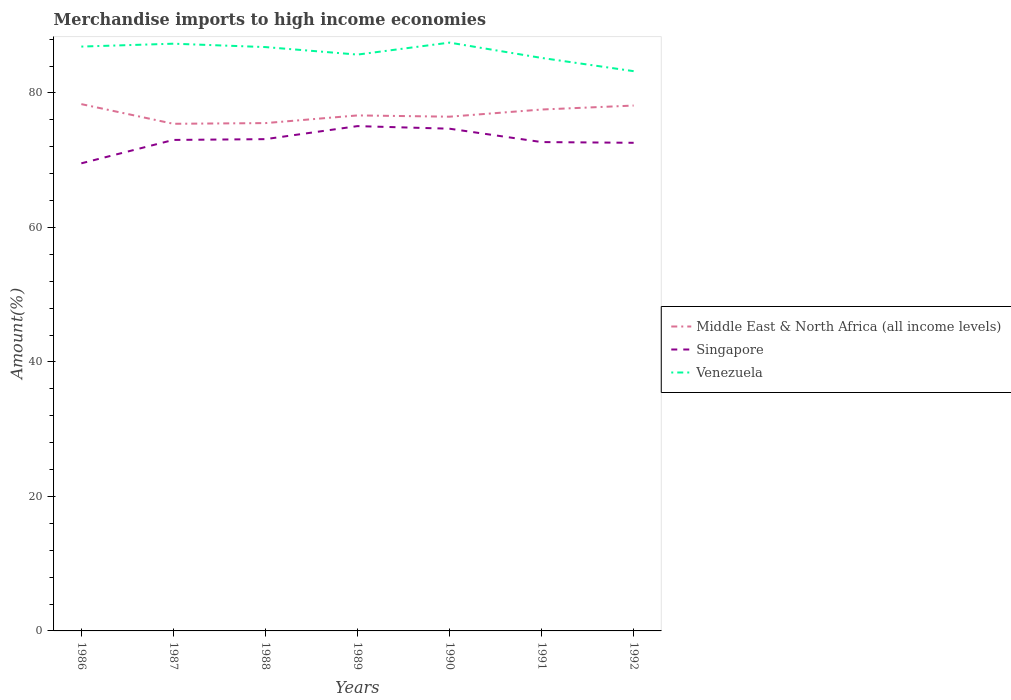How many different coloured lines are there?
Make the answer very short. 3. Does the line corresponding to Venezuela intersect with the line corresponding to Singapore?
Provide a succinct answer. No. Across all years, what is the maximum percentage of amount earned from merchandise imports in Middle East & North Africa (all income levels)?
Give a very brief answer. 75.41. In which year was the percentage of amount earned from merchandise imports in Venezuela maximum?
Offer a terse response. 1992. What is the total percentage of amount earned from merchandise imports in Singapore in the graph?
Keep it short and to the point. -1.55. What is the difference between the highest and the second highest percentage of amount earned from merchandise imports in Middle East & North Africa (all income levels)?
Your response must be concise. 2.93. Is the percentage of amount earned from merchandise imports in Venezuela strictly greater than the percentage of amount earned from merchandise imports in Singapore over the years?
Your answer should be very brief. No. How many lines are there?
Your response must be concise. 3. How many years are there in the graph?
Ensure brevity in your answer.  7. What is the difference between two consecutive major ticks on the Y-axis?
Provide a succinct answer. 20. Does the graph contain grids?
Offer a very short reply. No. How are the legend labels stacked?
Provide a short and direct response. Vertical. What is the title of the graph?
Your response must be concise. Merchandise imports to high income economies. What is the label or title of the Y-axis?
Your response must be concise. Amount(%). What is the Amount(%) in Middle East & North Africa (all income levels) in 1986?
Ensure brevity in your answer.  78.33. What is the Amount(%) of Singapore in 1986?
Your answer should be very brief. 69.53. What is the Amount(%) of Venezuela in 1986?
Offer a very short reply. 86.89. What is the Amount(%) in Middle East & North Africa (all income levels) in 1987?
Make the answer very short. 75.41. What is the Amount(%) in Singapore in 1987?
Make the answer very short. 73.01. What is the Amount(%) of Venezuela in 1987?
Provide a succinct answer. 87.32. What is the Amount(%) in Middle East & North Africa (all income levels) in 1988?
Your response must be concise. 75.51. What is the Amount(%) in Singapore in 1988?
Keep it short and to the point. 73.12. What is the Amount(%) of Venezuela in 1988?
Provide a short and direct response. 86.81. What is the Amount(%) of Middle East & North Africa (all income levels) in 1989?
Keep it short and to the point. 76.65. What is the Amount(%) of Singapore in 1989?
Offer a very short reply. 75.06. What is the Amount(%) of Venezuela in 1989?
Your answer should be very brief. 85.7. What is the Amount(%) of Middle East & North Africa (all income levels) in 1990?
Your answer should be compact. 76.46. What is the Amount(%) of Singapore in 1990?
Provide a short and direct response. 74.68. What is the Amount(%) in Venezuela in 1990?
Your response must be concise. 87.48. What is the Amount(%) in Middle East & North Africa (all income levels) in 1991?
Provide a succinct answer. 77.53. What is the Amount(%) of Singapore in 1991?
Your answer should be compact. 72.69. What is the Amount(%) of Venezuela in 1991?
Keep it short and to the point. 85.2. What is the Amount(%) in Middle East & North Africa (all income levels) in 1992?
Make the answer very short. 78.12. What is the Amount(%) in Singapore in 1992?
Keep it short and to the point. 72.58. What is the Amount(%) in Venezuela in 1992?
Provide a short and direct response. 83.23. Across all years, what is the maximum Amount(%) in Middle East & North Africa (all income levels)?
Your answer should be very brief. 78.33. Across all years, what is the maximum Amount(%) in Singapore?
Your response must be concise. 75.06. Across all years, what is the maximum Amount(%) in Venezuela?
Keep it short and to the point. 87.48. Across all years, what is the minimum Amount(%) of Middle East & North Africa (all income levels)?
Ensure brevity in your answer.  75.41. Across all years, what is the minimum Amount(%) in Singapore?
Give a very brief answer. 69.53. Across all years, what is the minimum Amount(%) in Venezuela?
Your answer should be compact. 83.23. What is the total Amount(%) of Middle East & North Africa (all income levels) in the graph?
Ensure brevity in your answer.  538.02. What is the total Amount(%) in Singapore in the graph?
Keep it short and to the point. 510.68. What is the total Amount(%) of Venezuela in the graph?
Your answer should be very brief. 602.63. What is the difference between the Amount(%) in Middle East & North Africa (all income levels) in 1986 and that in 1987?
Offer a terse response. 2.93. What is the difference between the Amount(%) in Singapore in 1986 and that in 1987?
Your answer should be very brief. -3.48. What is the difference between the Amount(%) in Venezuela in 1986 and that in 1987?
Keep it short and to the point. -0.43. What is the difference between the Amount(%) of Middle East & North Africa (all income levels) in 1986 and that in 1988?
Your answer should be very brief. 2.82. What is the difference between the Amount(%) in Singapore in 1986 and that in 1988?
Ensure brevity in your answer.  -3.6. What is the difference between the Amount(%) of Venezuela in 1986 and that in 1988?
Your response must be concise. 0.07. What is the difference between the Amount(%) of Middle East & North Africa (all income levels) in 1986 and that in 1989?
Make the answer very short. 1.68. What is the difference between the Amount(%) of Singapore in 1986 and that in 1989?
Provide a succinct answer. -5.53. What is the difference between the Amount(%) of Venezuela in 1986 and that in 1989?
Provide a short and direct response. 1.19. What is the difference between the Amount(%) in Middle East & North Africa (all income levels) in 1986 and that in 1990?
Make the answer very short. 1.87. What is the difference between the Amount(%) in Singapore in 1986 and that in 1990?
Offer a terse response. -5.15. What is the difference between the Amount(%) of Venezuela in 1986 and that in 1990?
Provide a succinct answer. -0.59. What is the difference between the Amount(%) in Middle East & North Africa (all income levels) in 1986 and that in 1991?
Your response must be concise. 0.8. What is the difference between the Amount(%) in Singapore in 1986 and that in 1991?
Ensure brevity in your answer.  -3.16. What is the difference between the Amount(%) in Venezuela in 1986 and that in 1991?
Make the answer very short. 1.69. What is the difference between the Amount(%) of Middle East & North Africa (all income levels) in 1986 and that in 1992?
Your response must be concise. 0.21. What is the difference between the Amount(%) in Singapore in 1986 and that in 1992?
Your answer should be compact. -3.05. What is the difference between the Amount(%) in Venezuela in 1986 and that in 1992?
Your answer should be compact. 3.66. What is the difference between the Amount(%) of Middle East & North Africa (all income levels) in 1987 and that in 1988?
Provide a succinct answer. -0.1. What is the difference between the Amount(%) in Singapore in 1987 and that in 1988?
Your response must be concise. -0.12. What is the difference between the Amount(%) in Venezuela in 1987 and that in 1988?
Offer a terse response. 0.5. What is the difference between the Amount(%) in Middle East & North Africa (all income levels) in 1987 and that in 1989?
Offer a terse response. -1.24. What is the difference between the Amount(%) of Singapore in 1987 and that in 1989?
Offer a terse response. -2.05. What is the difference between the Amount(%) of Venezuela in 1987 and that in 1989?
Give a very brief answer. 1.62. What is the difference between the Amount(%) of Middle East & North Africa (all income levels) in 1987 and that in 1990?
Keep it short and to the point. -1.06. What is the difference between the Amount(%) of Singapore in 1987 and that in 1990?
Give a very brief answer. -1.67. What is the difference between the Amount(%) of Venezuela in 1987 and that in 1990?
Make the answer very short. -0.16. What is the difference between the Amount(%) in Middle East & North Africa (all income levels) in 1987 and that in 1991?
Give a very brief answer. -2.12. What is the difference between the Amount(%) in Singapore in 1987 and that in 1991?
Make the answer very short. 0.32. What is the difference between the Amount(%) of Venezuela in 1987 and that in 1991?
Provide a short and direct response. 2.12. What is the difference between the Amount(%) in Middle East & North Africa (all income levels) in 1987 and that in 1992?
Provide a succinct answer. -2.71. What is the difference between the Amount(%) of Singapore in 1987 and that in 1992?
Offer a very short reply. 0.43. What is the difference between the Amount(%) of Venezuela in 1987 and that in 1992?
Ensure brevity in your answer.  4.08. What is the difference between the Amount(%) of Middle East & North Africa (all income levels) in 1988 and that in 1989?
Offer a terse response. -1.14. What is the difference between the Amount(%) in Singapore in 1988 and that in 1989?
Your answer should be compact. -1.94. What is the difference between the Amount(%) in Venezuela in 1988 and that in 1989?
Your answer should be very brief. 1.12. What is the difference between the Amount(%) in Middle East & North Africa (all income levels) in 1988 and that in 1990?
Provide a short and direct response. -0.95. What is the difference between the Amount(%) of Singapore in 1988 and that in 1990?
Offer a very short reply. -1.55. What is the difference between the Amount(%) of Venezuela in 1988 and that in 1990?
Your response must be concise. -0.66. What is the difference between the Amount(%) of Middle East & North Africa (all income levels) in 1988 and that in 1991?
Your response must be concise. -2.02. What is the difference between the Amount(%) in Singapore in 1988 and that in 1991?
Ensure brevity in your answer.  0.44. What is the difference between the Amount(%) in Venezuela in 1988 and that in 1991?
Make the answer very short. 1.61. What is the difference between the Amount(%) of Middle East & North Africa (all income levels) in 1988 and that in 1992?
Offer a terse response. -2.61. What is the difference between the Amount(%) in Singapore in 1988 and that in 1992?
Provide a succinct answer. 0.54. What is the difference between the Amount(%) in Venezuela in 1988 and that in 1992?
Keep it short and to the point. 3.58. What is the difference between the Amount(%) of Middle East & North Africa (all income levels) in 1989 and that in 1990?
Your response must be concise. 0.19. What is the difference between the Amount(%) of Singapore in 1989 and that in 1990?
Your answer should be very brief. 0.38. What is the difference between the Amount(%) of Venezuela in 1989 and that in 1990?
Keep it short and to the point. -1.78. What is the difference between the Amount(%) of Middle East & North Africa (all income levels) in 1989 and that in 1991?
Make the answer very short. -0.88. What is the difference between the Amount(%) of Singapore in 1989 and that in 1991?
Provide a short and direct response. 2.37. What is the difference between the Amount(%) of Venezuela in 1989 and that in 1991?
Offer a very short reply. 0.5. What is the difference between the Amount(%) in Middle East & North Africa (all income levels) in 1989 and that in 1992?
Make the answer very short. -1.47. What is the difference between the Amount(%) in Singapore in 1989 and that in 1992?
Your answer should be compact. 2.48. What is the difference between the Amount(%) of Venezuela in 1989 and that in 1992?
Your response must be concise. 2.46. What is the difference between the Amount(%) in Middle East & North Africa (all income levels) in 1990 and that in 1991?
Ensure brevity in your answer.  -1.06. What is the difference between the Amount(%) of Singapore in 1990 and that in 1991?
Ensure brevity in your answer.  1.99. What is the difference between the Amount(%) in Venezuela in 1990 and that in 1991?
Give a very brief answer. 2.28. What is the difference between the Amount(%) in Middle East & North Africa (all income levels) in 1990 and that in 1992?
Give a very brief answer. -1.66. What is the difference between the Amount(%) in Singapore in 1990 and that in 1992?
Keep it short and to the point. 2.09. What is the difference between the Amount(%) of Venezuela in 1990 and that in 1992?
Ensure brevity in your answer.  4.25. What is the difference between the Amount(%) of Middle East & North Africa (all income levels) in 1991 and that in 1992?
Your answer should be compact. -0.59. What is the difference between the Amount(%) in Singapore in 1991 and that in 1992?
Your answer should be very brief. 0.11. What is the difference between the Amount(%) of Venezuela in 1991 and that in 1992?
Make the answer very short. 1.97. What is the difference between the Amount(%) of Middle East & North Africa (all income levels) in 1986 and the Amount(%) of Singapore in 1987?
Your answer should be compact. 5.33. What is the difference between the Amount(%) of Middle East & North Africa (all income levels) in 1986 and the Amount(%) of Venezuela in 1987?
Give a very brief answer. -8.98. What is the difference between the Amount(%) of Singapore in 1986 and the Amount(%) of Venezuela in 1987?
Give a very brief answer. -17.79. What is the difference between the Amount(%) of Middle East & North Africa (all income levels) in 1986 and the Amount(%) of Singapore in 1988?
Ensure brevity in your answer.  5.21. What is the difference between the Amount(%) in Middle East & North Africa (all income levels) in 1986 and the Amount(%) in Venezuela in 1988?
Your answer should be compact. -8.48. What is the difference between the Amount(%) of Singapore in 1986 and the Amount(%) of Venezuela in 1988?
Ensure brevity in your answer.  -17.28. What is the difference between the Amount(%) of Middle East & North Africa (all income levels) in 1986 and the Amount(%) of Singapore in 1989?
Ensure brevity in your answer.  3.27. What is the difference between the Amount(%) of Middle East & North Africa (all income levels) in 1986 and the Amount(%) of Venezuela in 1989?
Your answer should be very brief. -7.36. What is the difference between the Amount(%) in Singapore in 1986 and the Amount(%) in Venezuela in 1989?
Offer a very short reply. -16.17. What is the difference between the Amount(%) in Middle East & North Africa (all income levels) in 1986 and the Amount(%) in Singapore in 1990?
Keep it short and to the point. 3.66. What is the difference between the Amount(%) in Middle East & North Africa (all income levels) in 1986 and the Amount(%) in Venezuela in 1990?
Your answer should be very brief. -9.15. What is the difference between the Amount(%) in Singapore in 1986 and the Amount(%) in Venezuela in 1990?
Your response must be concise. -17.95. What is the difference between the Amount(%) of Middle East & North Africa (all income levels) in 1986 and the Amount(%) of Singapore in 1991?
Keep it short and to the point. 5.64. What is the difference between the Amount(%) in Middle East & North Africa (all income levels) in 1986 and the Amount(%) in Venezuela in 1991?
Your response must be concise. -6.87. What is the difference between the Amount(%) in Singapore in 1986 and the Amount(%) in Venezuela in 1991?
Your answer should be compact. -15.67. What is the difference between the Amount(%) in Middle East & North Africa (all income levels) in 1986 and the Amount(%) in Singapore in 1992?
Keep it short and to the point. 5.75. What is the difference between the Amount(%) of Middle East & North Africa (all income levels) in 1986 and the Amount(%) of Venezuela in 1992?
Keep it short and to the point. -4.9. What is the difference between the Amount(%) in Singapore in 1986 and the Amount(%) in Venezuela in 1992?
Give a very brief answer. -13.7. What is the difference between the Amount(%) of Middle East & North Africa (all income levels) in 1987 and the Amount(%) of Singapore in 1988?
Give a very brief answer. 2.28. What is the difference between the Amount(%) of Middle East & North Africa (all income levels) in 1987 and the Amount(%) of Venezuela in 1988?
Your answer should be very brief. -11.41. What is the difference between the Amount(%) in Singapore in 1987 and the Amount(%) in Venezuela in 1988?
Ensure brevity in your answer.  -13.81. What is the difference between the Amount(%) in Middle East & North Africa (all income levels) in 1987 and the Amount(%) in Singapore in 1989?
Your answer should be compact. 0.35. What is the difference between the Amount(%) of Middle East & North Africa (all income levels) in 1987 and the Amount(%) of Venezuela in 1989?
Your answer should be compact. -10.29. What is the difference between the Amount(%) of Singapore in 1987 and the Amount(%) of Venezuela in 1989?
Provide a short and direct response. -12.69. What is the difference between the Amount(%) in Middle East & North Africa (all income levels) in 1987 and the Amount(%) in Singapore in 1990?
Offer a terse response. 0.73. What is the difference between the Amount(%) of Middle East & North Africa (all income levels) in 1987 and the Amount(%) of Venezuela in 1990?
Provide a short and direct response. -12.07. What is the difference between the Amount(%) in Singapore in 1987 and the Amount(%) in Venezuela in 1990?
Give a very brief answer. -14.47. What is the difference between the Amount(%) of Middle East & North Africa (all income levels) in 1987 and the Amount(%) of Singapore in 1991?
Ensure brevity in your answer.  2.72. What is the difference between the Amount(%) of Middle East & North Africa (all income levels) in 1987 and the Amount(%) of Venezuela in 1991?
Keep it short and to the point. -9.79. What is the difference between the Amount(%) in Singapore in 1987 and the Amount(%) in Venezuela in 1991?
Your response must be concise. -12.19. What is the difference between the Amount(%) of Middle East & North Africa (all income levels) in 1987 and the Amount(%) of Singapore in 1992?
Your answer should be very brief. 2.83. What is the difference between the Amount(%) in Middle East & North Africa (all income levels) in 1987 and the Amount(%) in Venezuela in 1992?
Your answer should be compact. -7.83. What is the difference between the Amount(%) in Singapore in 1987 and the Amount(%) in Venezuela in 1992?
Keep it short and to the point. -10.23. What is the difference between the Amount(%) of Middle East & North Africa (all income levels) in 1988 and the Amount(%) of Singapore in 1989?
Make the answer very short. 0.45. What is the difference between the Amount(%) of Middle East & North Africa (all income levels) in 1988 and the Amount(%) of Venezuela in 1989?
Give a very brief answer. -10.19. What is the difference between the Amount(%) in Singapore in 1988 and the Amount(%) in Venezuela in 1989?
Your answer should be compact. -12.57. What is the difference between the Amount(%) of Middle East & North Africa (all income levels) in 1988 and the Amount(%) of Singapore in 1990?
Make the answer very short. 0.83. What is the difference between the Amount(%) of Middle East & North Africa (all income levels) in 1988 and the Amount(%) of Venezuela in 1990?
Keep it short and to the point. -11.97. What is the difference between the Amount(%) in Singapore in 1988 and the Amount(%) in Venezuela in 1990?
Make the answer very short. -14.35. What is the difference between the Amount(%) of Middle East & North Africa (all income levels) in 1988 and the Amount(%) of Singapore in 1991?
Your answer should be very brief. 2.82. What is the difference between the Amount(%) of Middle East & North Africa (all income levels) in 1988 and the Amount(%) of Venezuela in 1991?
Provide a short and direct response. -9.69. What is the difference between the Amount(%) in Singapore in 1988 and the Amount(%) in Venezuela in 1991?
Keep it short and to the point. -12.08. What is the difference between the Amount(%) in Middle East & North Africa (all income levels) in 1988 and the Amount(%) in Singapore in 1992?
Offer a terse response. 2.93. What is the difference between the Amount(%) in Middle East & North Africa (all income levels) in 1988 and the Amount(%) in Venezuela in 1992?
Offer a terse response. -7.72. What is the difference between the Amount(%) of Singapore in 1988 and the Amount(%) of Venezuela in 1992?
Provide a short and direct response. -10.11. What is the difference between the Amount(%) of Middle East & North Africa (all income levels) in 1989 and the Amount(%) of Singapore in 1990?
Ensure brevity in your answer.  1.98. What is the difference between the Amount(%) in Middle East & North Africa (all income levels) in 1989 and the Amount(%) in Venezuela in 1990?
Your answer should be compact. -10.83. What is the difference between the Amount(%) of Singapore in 1989 and the Amount(%) of Venezuela in 1990?
Your answer should be compact. -12.42. What is the difference between the Amount(%) in Middle East & North Africa (all income levels) in 1989 and the Amount(%) in Singapore in 1991?
Provide a succinct answer. 3.96. What is the difference between the Amount(%) in Middle East & North Africa (all income levels) in 1989 and the Amount(%) in Venezuela in 1991?
Provide a succinct answer. -8.55. What is the difference between the Amount(%) in Singapore in 1989 and the Amount(%) in Venezuela in 1991?
Your answer should be compact. -10.14. What is the difference between the Amount(%) of Middle East & North Africa (all income levels) in 1989 and the Amount(%) of Singapore in 1992?
Your answer should be very brief. 4.07. What is the difference between the Amount(%) of Middle East & North Africa (all income levels) in 1989 and the Amount(%) of Venezuela in 1992?
Keep it short and to the point. -6.58. What is the difference between the Amount(%) in Singapore in 1989 and the Amount(%) in Venezuela in 1992?
Keep it short and to the point. -8.17. What is the difference between the Amount(%) in Middle East & North Africa (all income levels) in 1990 and the Amount(%) in Singapore in 1991?
Offer a terse response. 3.77. What is the difference between the Amount(%) in Middle East & North Africa (all income levels) in 1990 and the Amount(%) in Venezuela in 1991?
Provide a succinct answer. -8.74. What is the difference between the Amount(%) of Singapore in 1990 and the Amount(%) of Venezuela in 1991?
Ensure brevity in your answer.  -10.52. What is the difference between the Amount(%) of Middle East & North Africa (all income levels) in 1990 and the Amount(%) of Singapore in 1992?
Keep it short and to the point. 3.88. What is the difference between the Amount(%) in Middle East & North Africa (all income levels) in 1990 and the Amount(%) in Venezuela in 1992?
Offer a very short reply. -6.77. What is the difference between the Amount(%) of Singapore in 1990 and the Amount(%) of Venezuela in 1992?
Your answer should be very brief. -8.56. What is the difference between the Amount(%) of Middle East & North Africa (all income levels) in 1991 and the Amount(%) of Singapore in 1992?
Give a very brief answer. 4.95. What is the difference between the Amount(%) of Middle East & North Africa (all income levels) in 1991 and the Amount(%) of Venezuela in 1992?
Offer a terse response. -5.7. What is the difference between the Amount(%) of Singapore in 1991 and the Amount(%) of Venezuela in 1992?
Make the answer very short. -10.54. What is the average Amount(%) in Middle East & North Africa (all income levels) per year?
Offer a very short reply. 76.86. What is the average Amount(%) in Singapore per year?
Offer a terse response. 72.95. What is the average Amount(%) of Venezuela per year?
Keep it short and to the point. 86.09. In the year 1986, what is the difference between the Amount(%) of Middle East & North Africa (all income levels) and Amount(%) of Singapore?
Your answer should be very brief. 8.8. In the year 1986, what is the difference between the Amount(%) of Middle East & North Africa (all income levels) and Amount(%) of Venezuela?
Your response must be concise. -8.55. In the year 1986, what is the difference between the Amount(%) in Singapore and Amount(%) in Venezuela?
Ensure brevity in your answer.  -17.36. In the year 1987, what is the difference between the Amount(%) of Middle East & North Africa (all income levels) and Amount(%) of Singapore?
Your answer should be very brief. 2.4. In the year 1987, what is the difference between the Amount(%) in Middle East & North Africa (all income levels) and Amount(%) in Venezuela?
Your response must be concise. -11.91. In the year 1987, what is the difference between the Amount(%) in Singapore and Amount(%) in Venezuela?
Give a very brief answer. -14.31. In the year 1988, what is the difference between the Amount(%) in Middle East & North Africa (all income levels) and Amount(%) in Singapore?
Ensure brevity in your answer.  2.39. In the year 1988, what is the difference between the Amount(%) of Middle East & North Africa (all income levels) and Amount(%) of Venezuela?
Make the answer very short. -11.3. In the year 1988, what is the difference between the Amount(%) of Singapore and Amount(%) of Venezuela?
Give a very brief answer. -13.69. In the year 1989, what is the difference between the Amount(%) of Middle East & North Africa (all income levels) and Amount(%) of Singapore?
Give a very brief answer. 1.59. In the year 1989, what is the difference between the Amount(%) in Middle East & North Africa (all income levels) and Amount(%) in Venezuela?
Provide a succinct answer. -9.05. In the year 1989, what is the difference between the Amount(%) of Singapore and Amount(%) of Venezuela?
Give a very brief answer. -10.64. In the year 1990, what is the difference between the Amount(%) of Middle East & North Africa (all income levels) and Amount(%) of Singapore?
Your response must be concise. 1.79. In the year 1990, what is the difference between the Amount(%) in Middle East & North Africa (all income levels) and Amount(%) in Venezuela?
Offer a terse response. -11.01. In the year 1990, what is the difference between the Amount(%) in Singapore and Amount(%) in Venezuela?
Offer a very short reply. -12.8. In the year 1991, what is the difference between the Amount(%) in Middle East & North Africa (all income levels) and Amount(%) in Singapore?
Provide a short and direct response. 4.84. In the year 1991, what is the difference between the Amount(%) in Middle East & North Africa (all income levels) and Amount(%) in Venezuela?
Offer a very short reply. -7.67. In the year 1991, what is the difference between the Amount(%) in Singapore and Amount(%) in Venezuela?
Make the answer very short. -12.51. In the year 1992, what is the difference between the Amount(%) of Middle East & North Africa (all income levels) and Amount(%) of Singapore?
Your answer should be very brief. 5.54. In the year 1992, what is the difference between the Amount(%) of Middle East & North Africa (all income levels) and Amount(%) of Venezuela?
Offer a terse response. -5.11. In the year 1992, what is the difference between the Amount(%) of Singapore and Amount(%) of Venezuela?
Give a very brief answer. -10.65. What is the ratio of the Amount(%) of Middle East & North Africa (all income levels) in 1986 to that in 1987?
Offer a terse response. 1.04. What is the ratio of the Amount(%) in Singapore in 1986 to that in 1987?
Your response must be concise. 0.95. What is the ratio of the Amount(%) in Middle East & North Africa (all income levels) in 1986 to that in 1988?
Give a very brief answer. 1.04. What is the ratio of the Amount(%) of Singapore in 1986 to that in 1988?
Provide a short and direct response. 0.95. What is the ratio of the Amount(%) in Venezuela in 1986 to that in 1988?
Your answer should be very brief. 1. What is the ratio of the Amount(%) of Middle East & North Africa (all income levels) in 1986 to that in 1989?
Offer a terse response. 1.02. What is the ratio of the Amount(%) in Singapore in 1986 to that in 1989?
Provide a short and direct response. 0.93. What is the ratio of the Amount(%) of Venezuela in 1986 to that in 1989?
Keep it short and to the point. 1.01. What is the ratio of the Amount(%) of Middle East & North Africa (all income levels) in 1986 to that in 1990?
Provide a short and direct response. 1.02. What is the ratio of the Amount(%) of Singapore in 1986 to that in 1990?
Offer a very short reply. 0.93. What is the ratio of the Amount(%) in Middle East & North Africa (all income levels) in 1986 to that in 1991?
Ensure brevity in your answer.  1.01. What is the ratio of the Amount(%) of Singapore in 1986 to that in 1991?
Provide a succinct answer. 0.96. What is the ratio of the Amount(%) in Venezuela in 1986 to that in 1991?
Provide a succinct answer. 1.02. What is the ratio of the Amount(%) in Middle East & North Africa (all income levels) in 1986 to that in 1992?
Make the answer very short. 1. What is the ratio of the Amount(%) in Singapore in 1986 to that in 1992?
Provide a short and direct response. 0.96. What is the ratio of the Amount(%) in Venezuela in 1986 to that in 1992?
Keep it short and to the point. 1.04. What is the ratio of the Amount(%) in Middle East & North Africa (all income levels) in 1987 to that in 1989?
Provide a short and direct response. 0.98. What is the ratio of the Amount(%) in Singapore in 1987 to that in 1989?
Ensure brevity in your answer.  0.97. What is the ratio of the Amount(%) in Venezuela in 1987 to that in 1989?
Your answer should be compact. 1.02. What is the ratio of the Amount(%) of Middle East & North Africa (all income levels) in 1987 to that in 1990?
Ensure brevity in your answer.  0.99. What is the ratio of the Amount(%) of Singapore in 1987 to that in 1990?
Make the answer very short. 0.98. What is the ratio of the Amount(%) in Middle East & North Africa (all income levels) in 1987 to that in 1991?
Offer a terse response. 0.97. What is the ratio of the Amount(%) of Singapore in 1987 to that in 1991?
Provide a short and direct response. 1. What is the ratio of the Amount(%) of Venezuela in 1987 to that in 1991?
Ensure brevity in your answer.  1.02. What is the ratio of the Amount(%) in Middle East & North Africa (all income levels) in 1987 to that in 1992?
Give a very brief answer. 0.97. What is the ratio of the Amount(%) of Singapore in 1987 to that in 1992?
Your response must be concise. 1.01. What is the ratio of the Amount(%) in Venezuela in 1987 to that in 1992?
Keep it short and to the point. 1.05. What is the ratio of the Amount(%) of Middle East & North Africa (all income levels) in 1988 to that in 1989?
Your answer should be compact. 0.99. What is the ratio of the Amount(%) of Singapore in 1988 to that in 1989?
Give a very brief answer. 0.97. What is the ratio of the Amount(%) of Venezuela in 1988 to that in 1989?
Give a very brief answer. 1.01. What is the ratio of the Amount(%) in Middle East & North Africa (all income levels) in 1988 to that in 1990?
Provide a succinct answer. 0.99. What is the ratio of the Amount(%) of Singapore in 1988 to that in 1990?
Your answer should be very brief. 0.98. What is the ratio of the Amount(%) of Middle East & North Africa (all income levels) in 1988 to that in 1991?
Your answer should be compact. 0.97. What is the ratio of the Amount(%) of Venezuela in 1988 to that in 1991?
Offer a very short reply. 1.02. What is the ratio of the Amount(%) in Middle East & North Africa (all income levels) in 1988 to that in 1992?
Your answer should be very brief. 0.97. What is the ratio of the Amount(%) of Singapore in 1988 to that in 1992?
Provide a short and direct response. 1.01. What is the ratio of the Amount(%) in Venezuela in 1988 to that in 1992?
Ensure brevity in your answer.  1.04. What is the ratio of the Amount(%) of Venezuela in 1989 to that in 1990?
Provide a succinct answer. 0.98. What is the ratio of the Amount(%) of Middle East & North Africa (all income levels) in 1989 to that in 1991?
Ensure brevity in your answer.  0.99. What is the ratio of the Amount(%) of Singapore in 1989 to that in 1991?
Make the answer very short. 1.03. What is the ratio of the Amount(%) in Venezuela in 1989 to that in 1991?
Give a very brief answer. 1.01. What is the ratio of the Amount(%) of Middle East & North Africa (all income levels) in 1989 to that in 1992?
Provide a succinct answer. 0.98. What is the ratio of the Amount(%) of Singapore in 1989 to that in 1992?
Give a very brief answer. 1.03. What is the ratio of the Amount(%) in Venezuela in 1989 to that in 1992?
Provide a succinct answer. 1.03. What is the ratio of the Amount(%) of Middle East & North Africa (all income levels) in 1990 to that in 1991?
Ensure brevity in your answer.  0.99. What is the ratio of the Amount(%) of Singapore in 1990 to that in 1991?
Your response must be concise. 1.03. What is the ratio of the Amount(%) in Venezuela in 1990 to that in 1991?
Ensure brevity in your answer.  1.03. What is the ratio of the Amount(%) in Middle East & North Africa (all income levels) in 1990 to that in 1992?
Keep it short and to the point. 0.98. What is the ratio of the Amount(%) in Singapore in 1990 to that in 1992?
Ensure brevity in your answer.  1.03. What is the ratio of the Amount(%) in Venezuela in 1990 to that in 1992?
Keep it short and to the point. 1.05. What is the ratio of the Amount(%) in Venezuela in 1991 to that in 1992?
Your answer should be compact. 1.02. What is the difference between the highest and the second highest Amount(%) of Middle East & North Africa (all income levels)?
Your response must be concise. 0.21. What is the difference between the highest and the second highest Amount(%) of Singapore?
Your answer should be compact. 0.38. What is the difference between the highest and the second highest Amount(%) in Venezuela?
Offer a very short reply. 0.16. What is the difference between the highest and the lowest Amount(%) of Middle East & North Africa (all income levels)?
Your answer should be very brief. 2.93. What is the difference between the highest and the lowest Amount(%) of Singapore?
Offer a terse response. 5.53. What is the difference between the highest and the lowest Amount(%) of Venezuela?
Give a very brief answer. 4.25. 